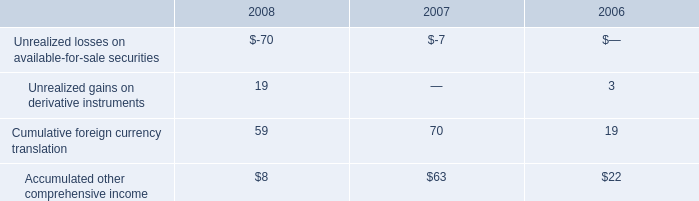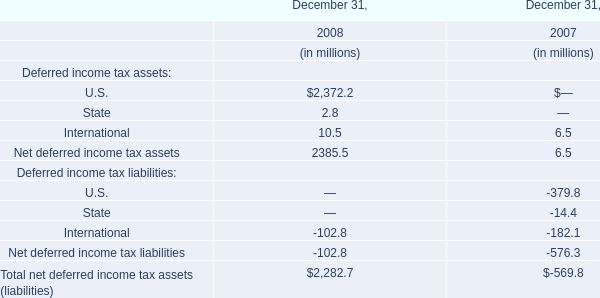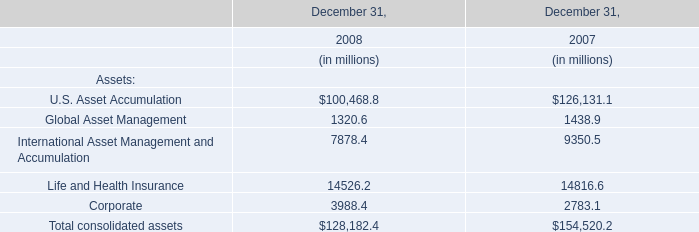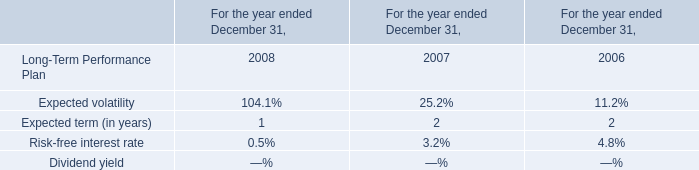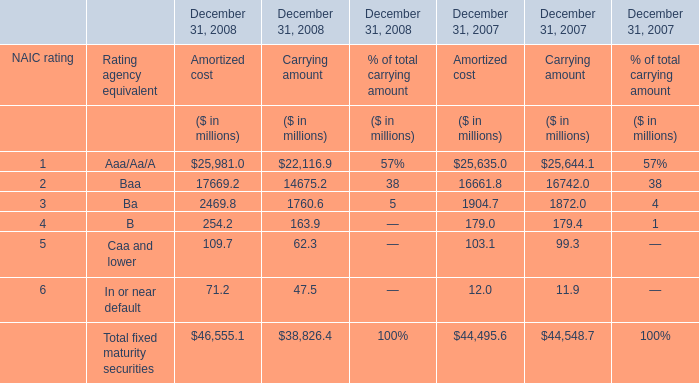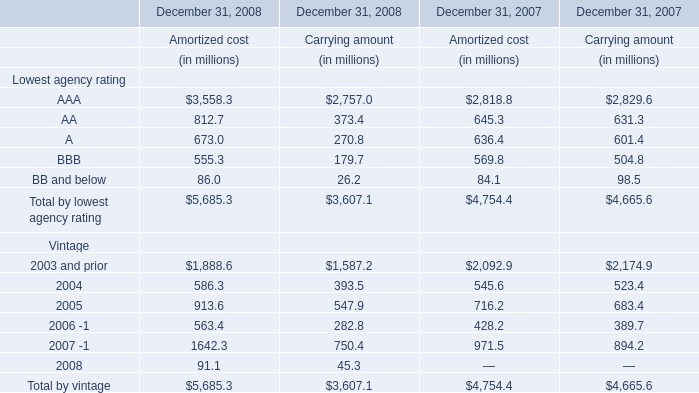What is the Carrying amount of the Total fixed maturity securities at December 31, 2008? (in million) 
Answer: 38826.4. 